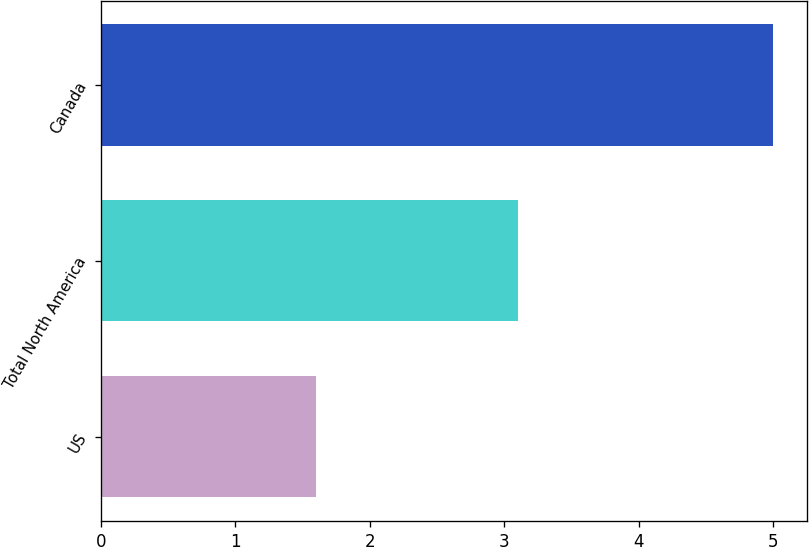Convert chart to OTSL. <chart><loc_0><loc_0><loc_500><loc_500><bar_chart><fcel>US<fcel>Total North America<fcel>Canada<nl><fcel>1.6<fcel>3.1<fcel>5<nl></chart> 